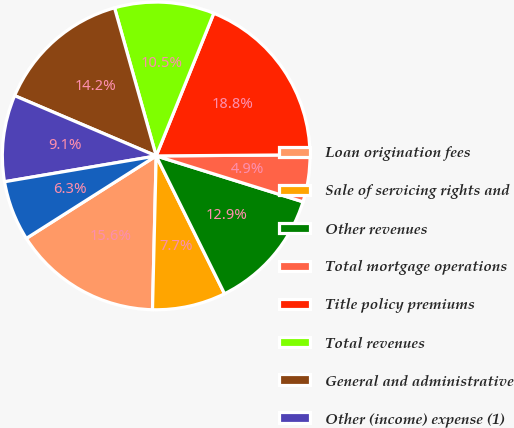<chart> <loc_0><loc_0><loc_500><loc_500><pie_chart><fcel>Loan origination fees<fcel>Sale of servicing rights and<fcel>Other revenues<fcel>Total mortgage operations<fcel>Title policy premiums<fcel>Total revenues<fcel>General and administrative<fcel>Other (income) expense (1)<fcel>Financial services pre-tax<nl><fcel>15.61%<fcel>7.71%<fcel>12.85%<fcel>4.94%<fcel>18.77%<fcel>10.47%<fcel>14.23%<fcel>9.09%<fcel>6.32%<nl></chart> 